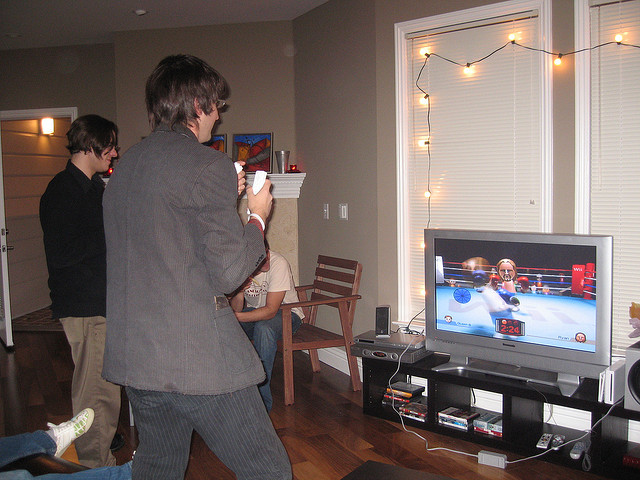<image>Which item is plaid? I don't know which item is plaid, could be the jacket, shirt, or pants. Which item is plaid? I don't know which item is plaid. It can be either the jacket or the shirt. 